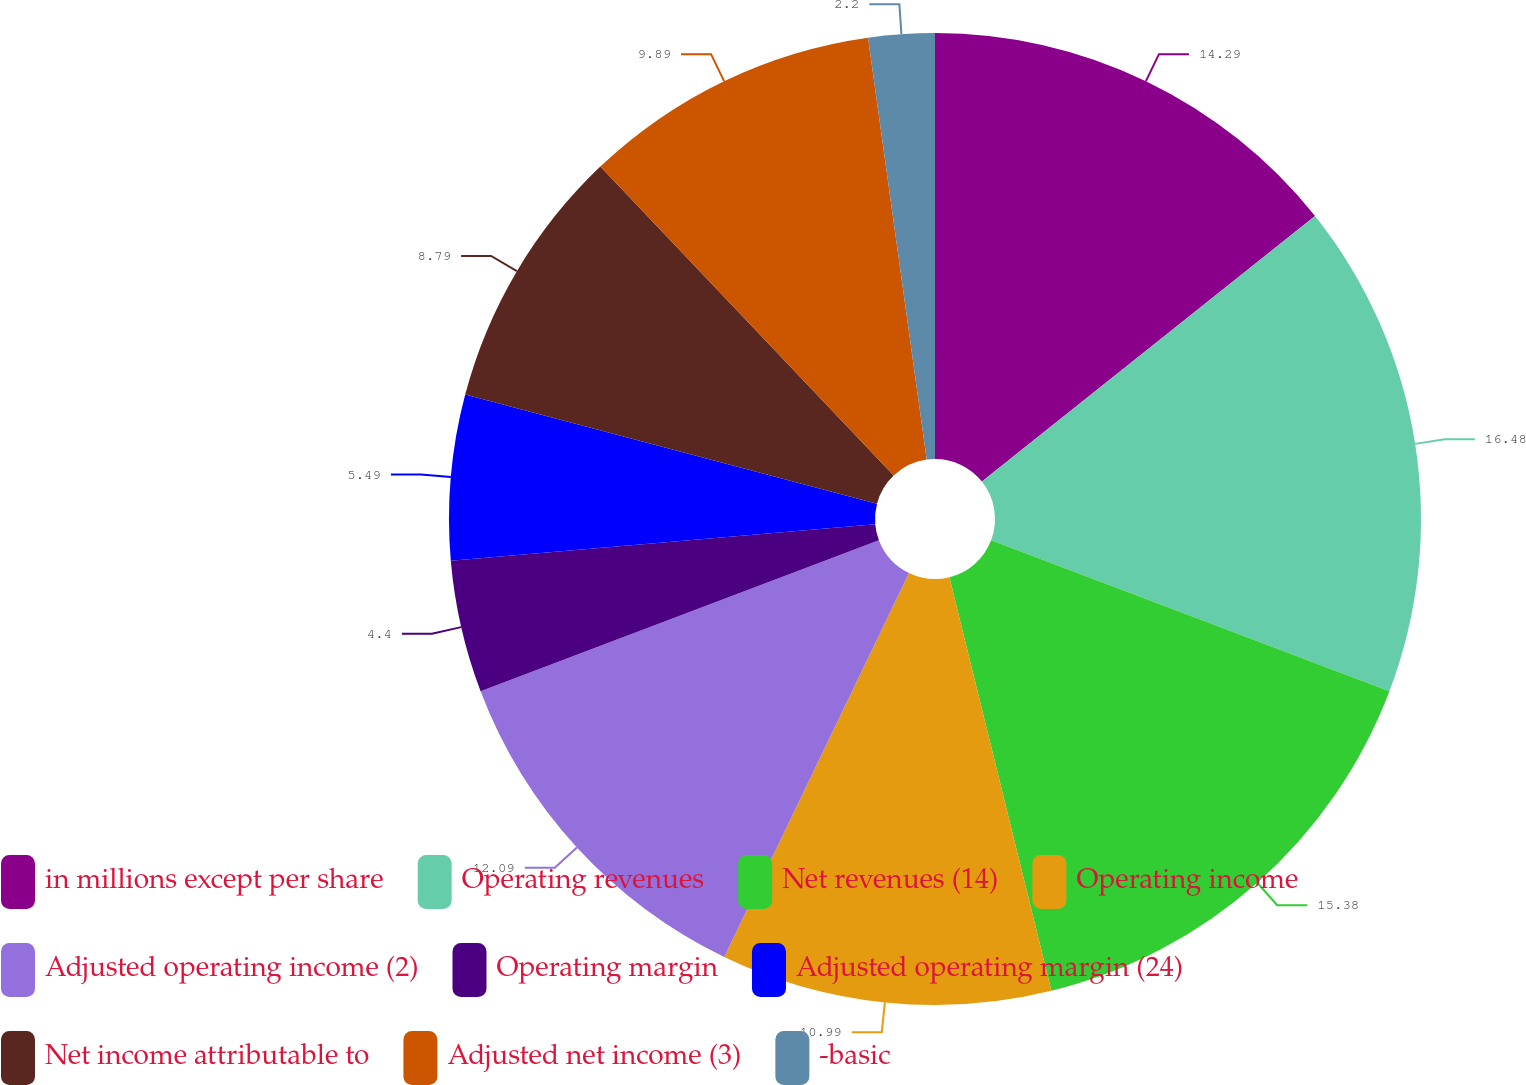Convert chart. <chart><loc_0><loc_0><loc_500><loc_500><pie_chart><fcel>in millions except per share<fcel>Operating revenues<fcel>Net revenues (14)<fcel>Operating income<fcel>Adjusted operating income (2)<fcel>Operating margin<fcel>Adjusted operating margin (24)<fcel>Net income attributable to<fcel>Adjusted net income (3)<fcel>-basic<nl><fcel>14.29%<fcel>16.48%<fcel>15.38%<fcel>10.99%<fcel>12.09%<fcel>4.4%<fcel>5.49%<fcel>8.79%<fcel>9.89%<fcel>2.2%<nl></chart> 